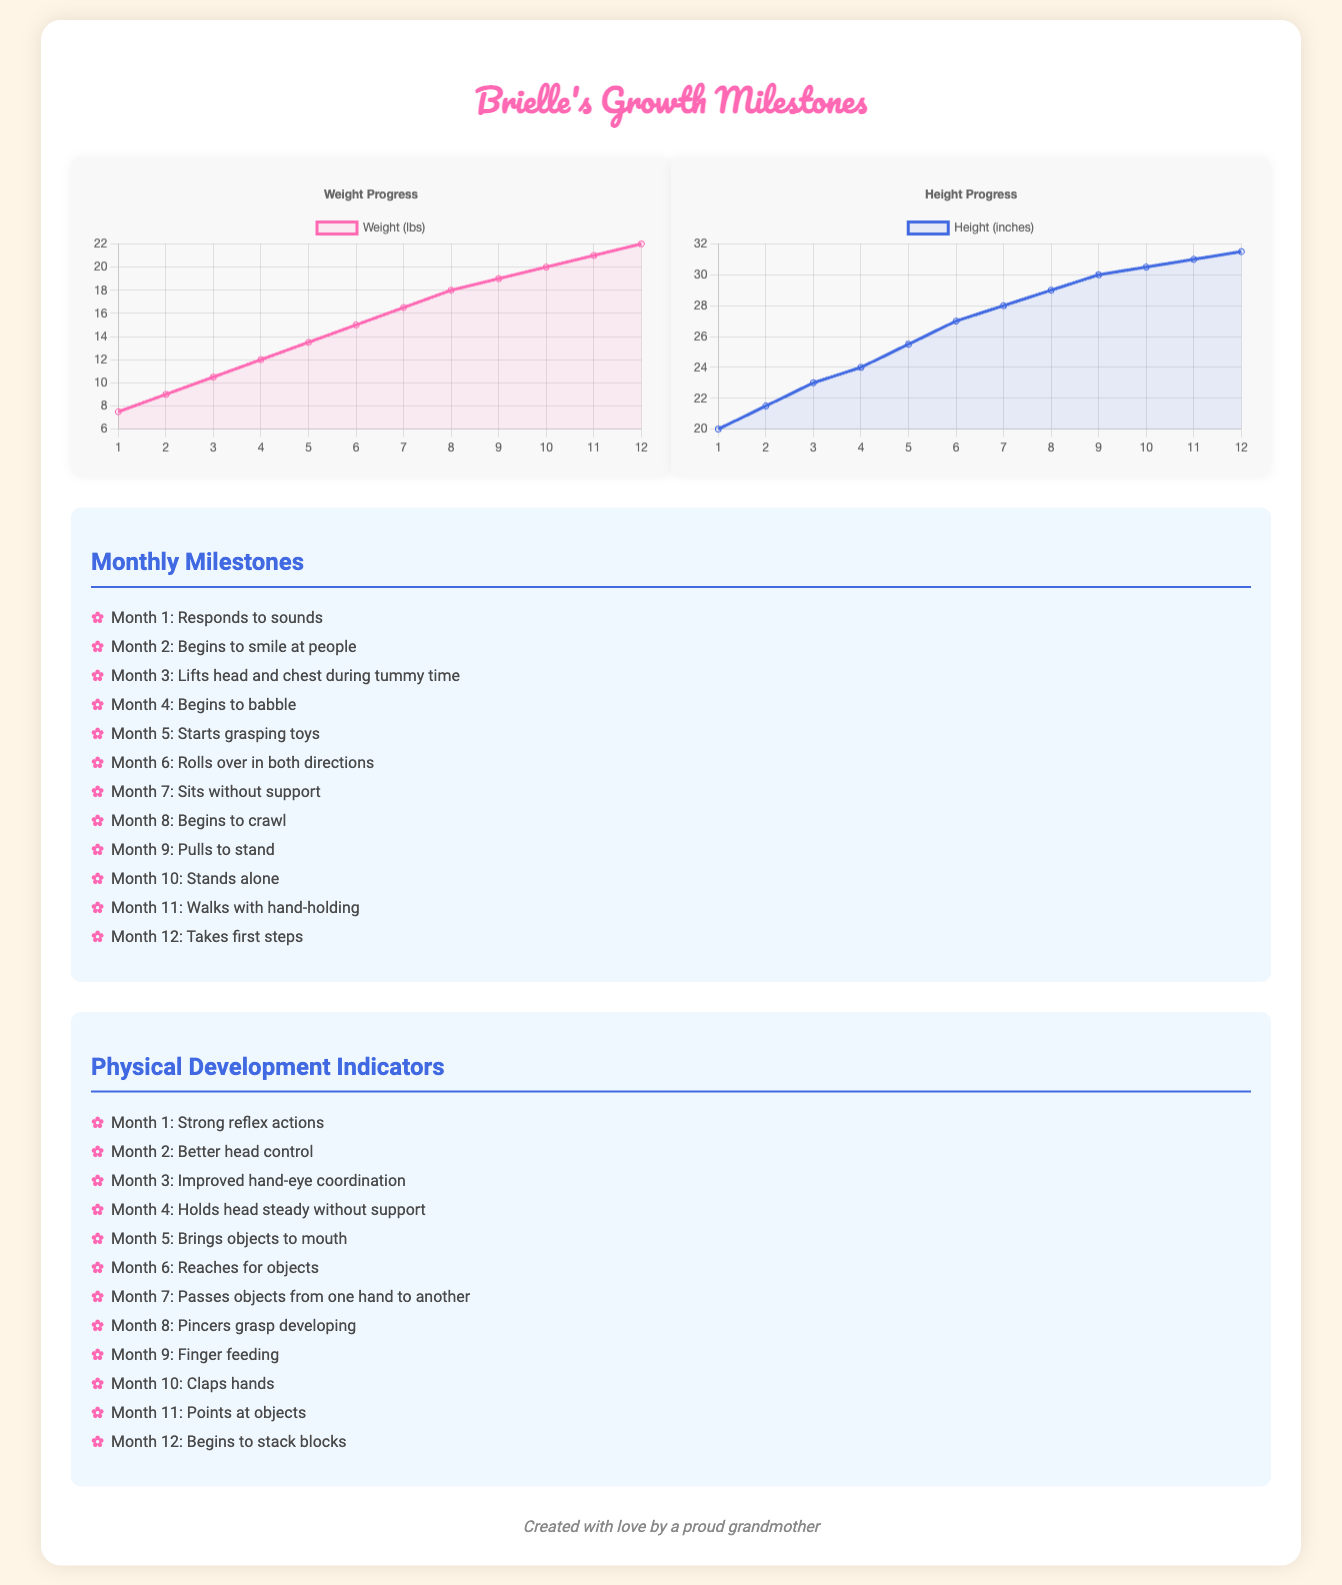What is Brielle's weight at Month 6? The document states that Brielle's weight for Month 6 is 15 lbs.
Answer: 15 lbs What milestone does Brielle reach in Month 9? In Month 9, Brielle pulls to stand according to the milestones listed.
Answer: Pulls to stand Which month shows Brielle's height reaching 30 inches? The document indicates that Brielle reaches 30 inches in Month 9.
Answer: Month 9 What is the weight of Brielle in Month 12? The weight documented for Month 12 is 22 lbs.
Answer: 22 lbs In which month does Brielle begin to crawl? Month 8 is when Brielle begins to crawl, as per the milestones.
Answer: Month 8 What is the highest weight recorded in the chart? The highest weight recorded for Brielle is 22 lbs in Month 12.
Answer: 22 lbs What physical development milestone occurs in Month 5? Month 5 includes the milestone of bringing objects to mouth.
Answer: Brings objects to mouth What is the title of the second chart? The title for the second chart is 'Height Progress'.
Answer: Height Progress Which color represents Brielle's weight in the chart? The color representing Brielle's weight is pink.
Answer: Pink 